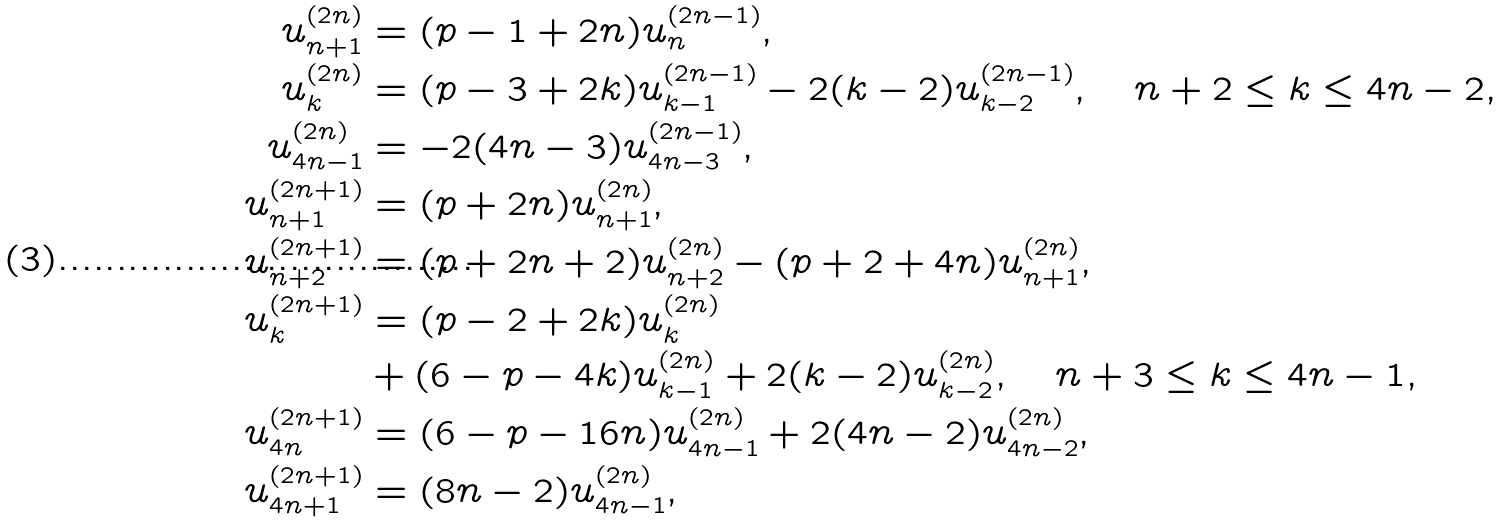Convert formula to latex. <formula><loc_0><loc_0><loc_500><loc_500>u _ { n + 1 } ^ { ( 2 n ) } & = ( p - 1 + 2 n ) u _ { n } ^ { ( 2 n - 1 ) } , \\ u _ { k } ^ { ( 2 n ) } & = ( p - 3 + 2 k ) u _ { k - 1 } ^ { ( 2 n - 1 ) } - 2 ( k - 2 ) u _ { k - 2 } ^ { ( 2 n - 1 ) } , \quad n + 2 \leq k \leq 4 n - 2 , \\ u _ { 4 n - 1 } ^ { ( 2 n ) } & = - 2 ( 4 n - 3 ) u _ { 4 n - 3 } ^ { ( 2 n - 1 ) } , \\ u _ { n + 1 } ^ { ( 2 n + 1 ) } & = ( p + 2 n ) u _ { n + 1 } ^ { ( 2 n ) } , \\ u _ { n + 2 } ^ { ( 2 n + 1 ) } & = ( p + 2 n + 2 ) u _ { n + 2 } ^ { ( 2 n ) } - ( p + 2 + 4 n ) u _ { n + 1 } ^ { ( 2 n ) } , \\ u _ { k } ^ { ( 2 n + 1 ) } & = ( p - 2 + 2 k ) u _ { k } ^ { ( 2 n ) } \\ & + ( 6 - p - 4 k ) u _ { k - 1 } ^ { ( 2 n ) } + 2 ( k - 2 ) u _ { k - 2 } ^ { ( 2 n ) } , \quad n + 3 \leq k \leq 4 n - 1 , \\ u _ { 4 n } ^ { ( 2 n + 1 ) } & = ( 6 - p - 1 6 n ) u _ { 4 n - 1 } ^ { ( 2 n ) } + 2 ( 4 n - 2 ) u _ { 4 n - 2 } ^ { ( 2 n ) } , \\ u _ { 4 n + 1 } ^ { ( 2 n + 1 ) } & = ( 8 n - 2 ) u _ { 4 n - 1 } ^ { ( 2 n ) } ,</formula> 